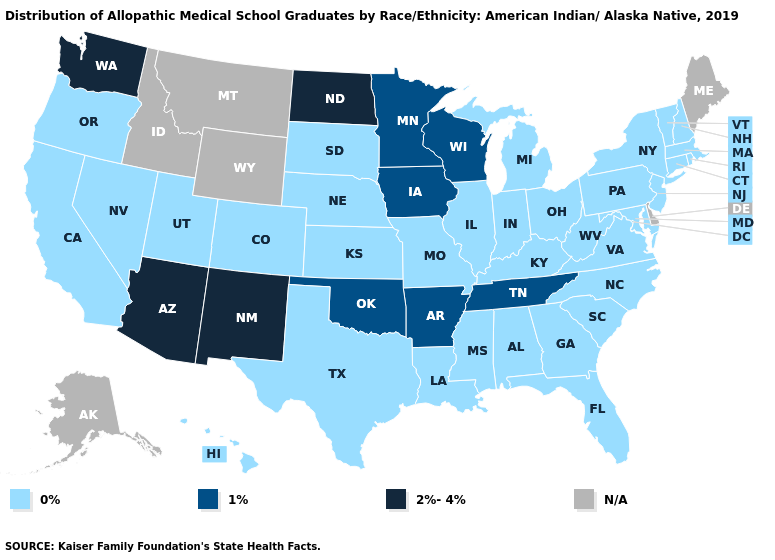Among the states that border Missouri , which have the lowest value?
Answer briefly. Illinois, Kansas, Kentucky, Nebraska. What is the value of Georgia?
Be succinct. 0%. Does Georgia have the lowest value in the South?
Short answer required. Yes. What is the lowest value in the Northeast?
Write a very short answer. 0%. Is the legend a continuous bar?
Be succinct. No. Name the states that have a value in the range N/A?
Be succinct. Alaska, Delaware, Idaho, Maine, Montana, Wyoming. Does Iowa have the highest value in the MidWest?
Keep it brief. No. What is the highest value in the South ?
Write a very short answer. 1%. Name the states that have a value in the range N/A?
Be succinct. Alaska, Delaware, Idaho, Maine, Montana, Wyoming. Which states have the lowest value in the USA?
Quick response, please. Alabama, California, Colorado, Connecticut, Florida, Georgia, Hawaii, Illinois, Indiana, Kansas, Kentucky, Louisiana, Maryland, Massachusetts, Michigan, Mississippi, Missouri, Nebraska, Nevada, New Hampshire, New Jersey, New York, North Carolina, Ohio, Oregon, Pennsylvania, Rhode Island, South Carolina, South Dakota, Texas, Utah, Vermont, Virginia, West Virginia. Which states have the highest value in the USA?
Write a very short answer. Arizona, New Mexico, North Dakota, Washington. Which states have the lowest value in the South?
Keep it brief. Alabama, Florida, Georgia, Kentucky, Louisiana, Maryland, Mississippi, North Carolina, South Carolina, Texas, Virginia, West Virginia. What is the highest value in the USA?
Write a very short answer. 2%-4%. What is the lowest value in the MidWest?
Give a very brief answer. 0%. 